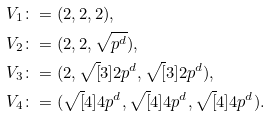<formula> <loc_0><loc_0><loc_500><loc_500>V _ { 1 } & \colon = ( 2 , 2 , 2 ) , \\ V _ { 2 } & \colon = ( 2 , 2 , \sqrt { p ^ { d } } ) , \\ V _ { 3 } & \colon = ( 2 , \sqrt { [ } 3 ] { 2 p ^ { d } } , \sqrt { [ } 3 ] { 2 p ^ { d } } ) , \\ V _ { 4 } & \colon = ( \sqrt { [ } 4 ] { 4 p ^ { d } } , \sqrt { [ } 4 ] { 4 p ^ { d } } , \sqrt { [ } 4 ] { 4 p ^ { d } } ) .</formula> 